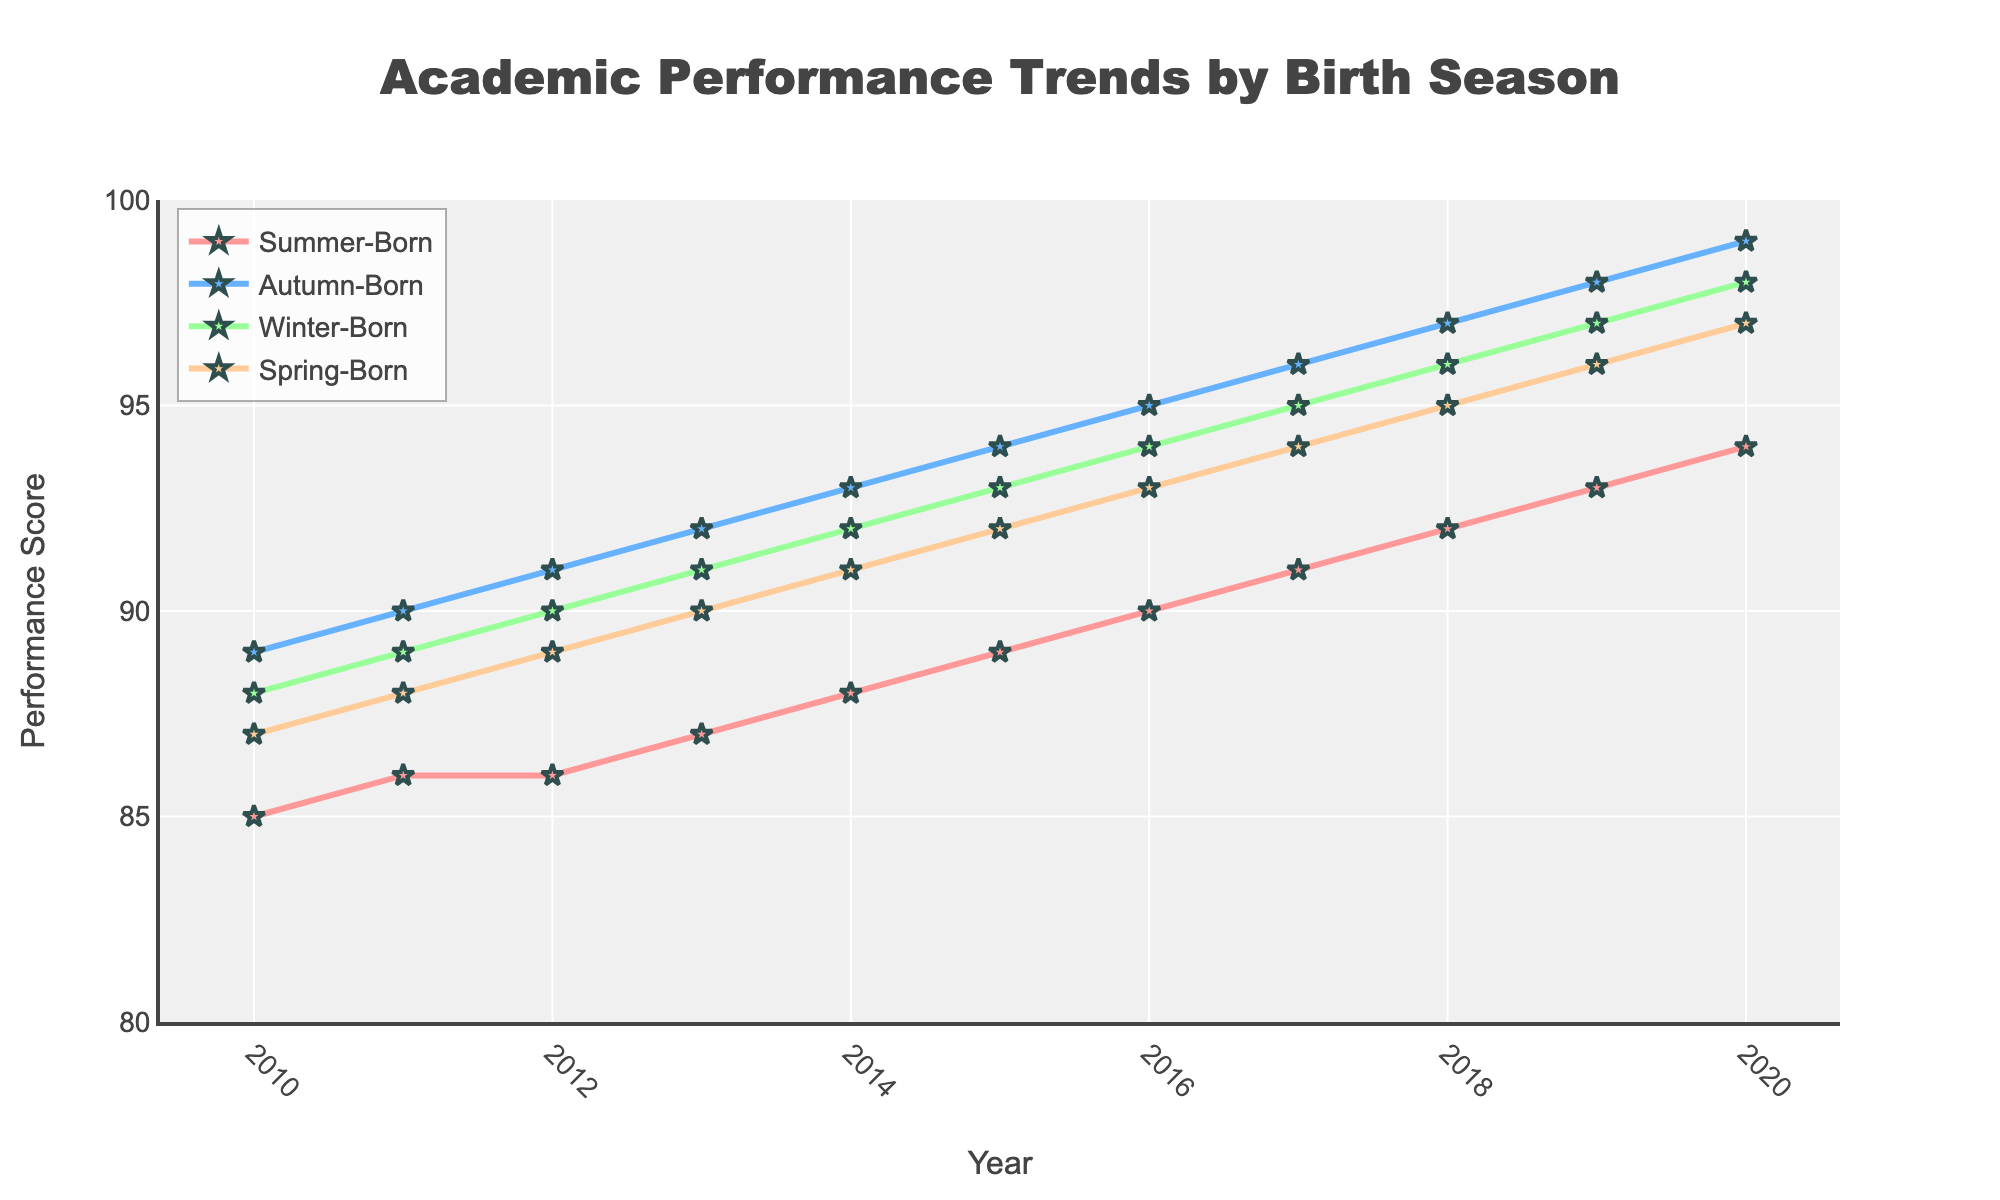What is the overall trend in academic performance for summer-born children from 2010 to 2020? The line representing summer-born children's performance shows a gradual increase from 85 in 2010 to 94 in 2020, indicating an overall improving trend.
Answer: Increasing How does the performance of summer-born children in 2015 compare to autumn-born children in the same year? In 2015, summer-born children had a performance score of 89, while autumn-born children had a score of 94. Thus, autumn-born children performed better than summer-born children by 5 points.
Answer: Autumn-born performed better by 5 points Which birth season had the highest academic performance in 2018? The line for autumn-born children in 2018 is highest with a score of 97, making autumn-born the top performers in that year.
Answer: Autumn-born Calculate the difference in academic performance between winter-born children and spring-born children in 2012. In 2012, winter-born children had a score of 90, and spring-born children had a score of 89. The difference is 90 - 89 = 1.
Answer: 1 What is the visual difference between the performance trends of summer-born and winter-born children over the decade? The summer-born children's trend line (red) starts lower and rises more steadily, while the winter-born children's trend line (green) starts higher and follows a similar increasing pattern, but always remains above the summer-born line.
Answer: Winter-born line always above By how much did the performance score of spring-born children increase from 2010 to 2020? Spring-born children's performance score increased from 87 in 2010 to 97 in 2020. The increase is 97 - 87 = 10.
Answer: 10 Identify the year when the gap between summer-born and autumn-born children's performance was the smallest. The gap is smallest in 2020, where summer-born have 94 and autumn-born have 99, making the gap 5 points, which is the smallest gap compared to other years.
Answer: 2020 What color represents the summer-born children in the chart? The line and markers for summer-born children are red in color.
Answer: Red Is there any year when the performance score for summer-born children was higher than spring-born children? No, at all points in the chart from 2010 to 2020, the performance score of spring-born children remains above that of summer-born children.
Answer: No Find the average performance score of winter-born children from 2010 to 2020. The sum of winter-born children's scores from 2010 to 2020 is 88 + 89 + 90 + 91 + 92 + 93 + 94 + 95 + 96 + 97 + 98 = 1023. There are 11 years, so the average is 1023 / 11 = 93.
Answer: 93 